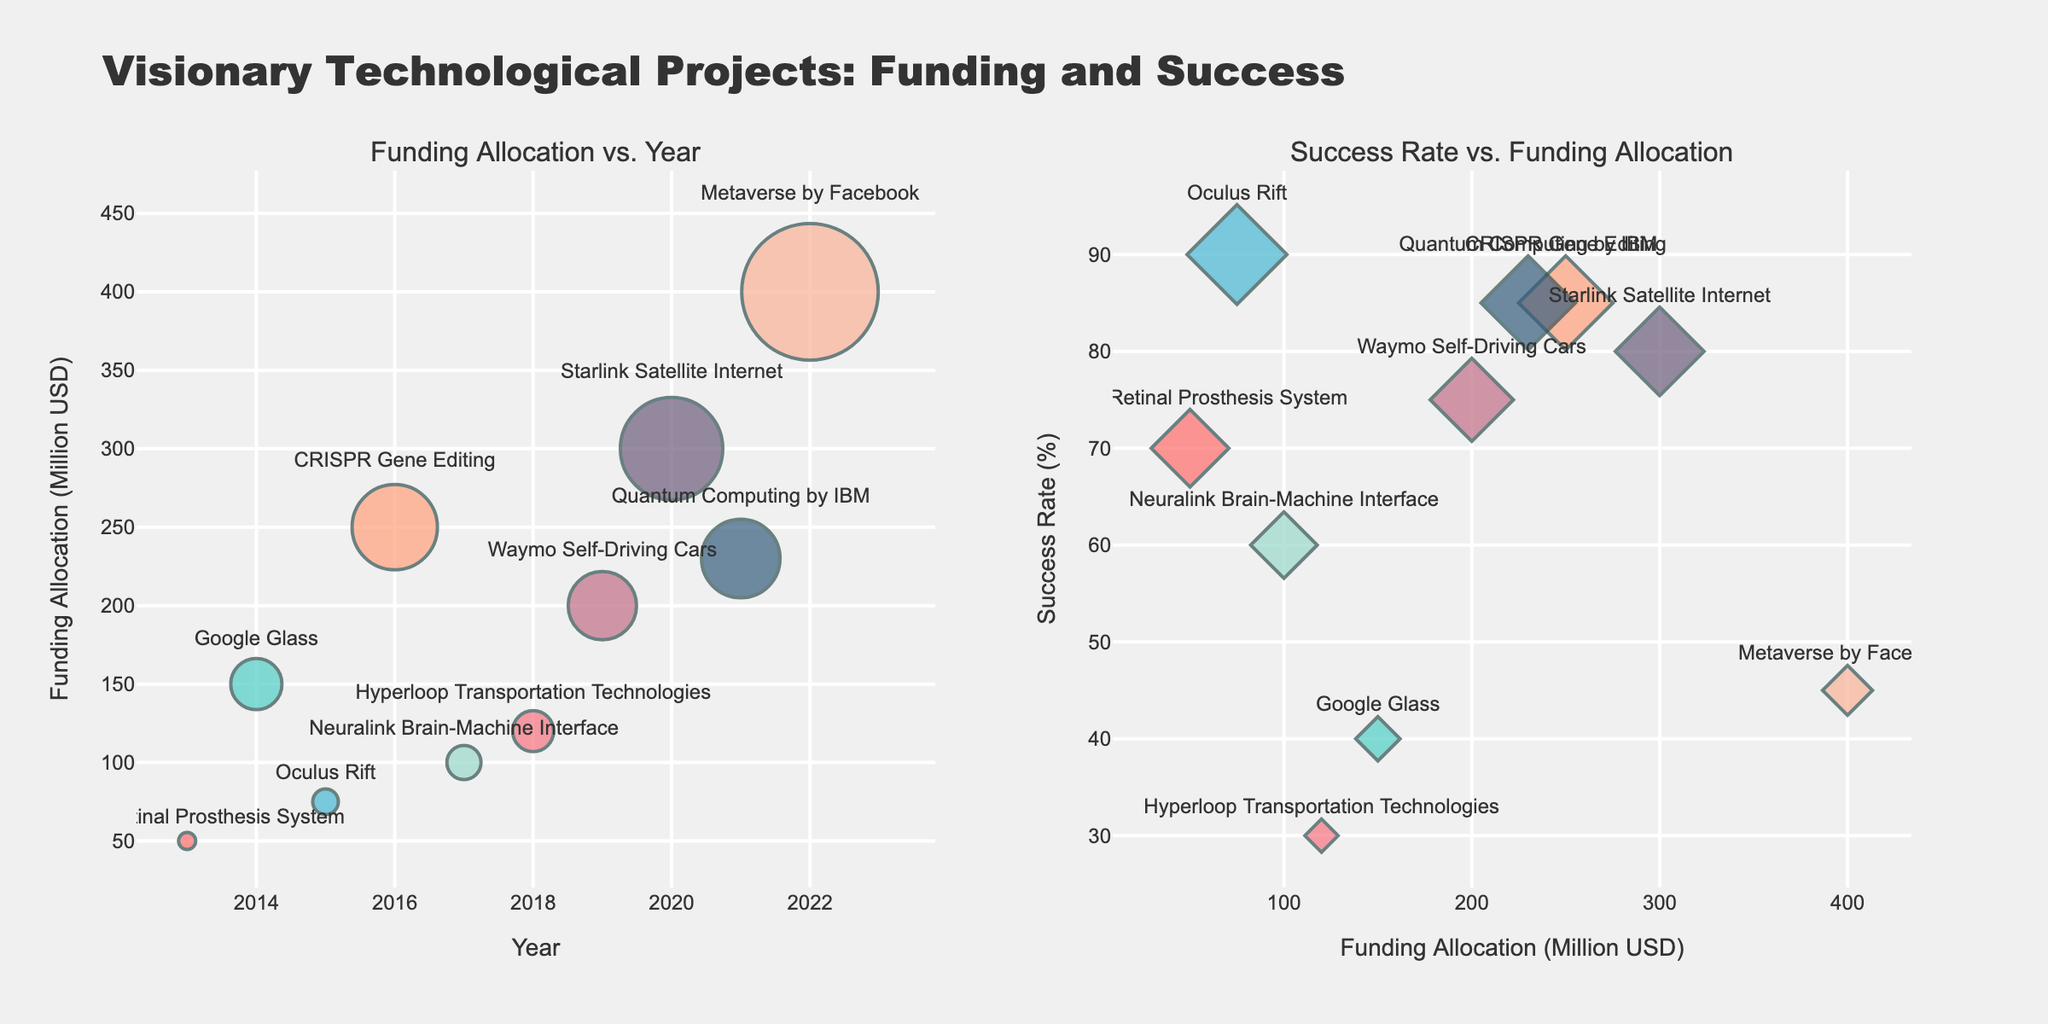How many projects are plotted in the second subplot? To identify the number of projects in the second subplot, visually count the number of distinct data points displayed.
Answer: 10 Which project received the highest funding? Identify the data point with the maximum value on the x-axis in the second subplot. Hover over the data point to confirm the project's name.
Answer: Metaverse by Facebook What is the success rate of the Argus II Retinal Prosthesis System? Locate the Argus II Retinal Prosthesis System in the legend or by hovering over its corresponding data point and read off its y-value in the second subplot.
Answer: 70% Which project had the lowest success rate? Identify the data point with the minimum value on the y-axis in the second subplot. Hover over the point to confirm the project's name.
Answer: Hyperloop Transportation Technologies How does the funding allocation of Neuralink in 2017 compare to that of CRISPR Gene Editing in 2016? Find the data points for both Neuralink in 2017 and CRISPR Gene Editing in 2016 on the first subplot and compare their y-values for funding allocation.
Answer: Neuralink's funding is lower (100M vs 250M) What is the average success rate of all projects over the last decade? Add the success rates of all projects and divide by the number of projects to find the average. \( (70 + 40 + 90 + 85 + 60 + 30 + 75 + 80 + 85 + 45) / 10 = 66% \)
Answer: 66% Which two projects have equal success rates, and what are they? Locate and match data points in the second subplot that share the same y-value for success rate.
Answer: CRISPR Gene Editing and Quantum Computing by IBM (both 85%) How does the funding allocation trend over the years? Observe the general direction of the data points along the x-axis in the first subplot.
Answer: Generally increasing Which project saw the second highest funding, and what was the success rate? Identify the data point with the second highest x-value in the second subplot and hover over to find the corresponding success rate.
Answer: Quantum Computing by IBM, 85% What is the range of success rates among the plotted projects? Identify the maximum and minimum y-values in the second subplot and calculate the difference. \( 90 - 30 = 60% \)
Answer: 60% 